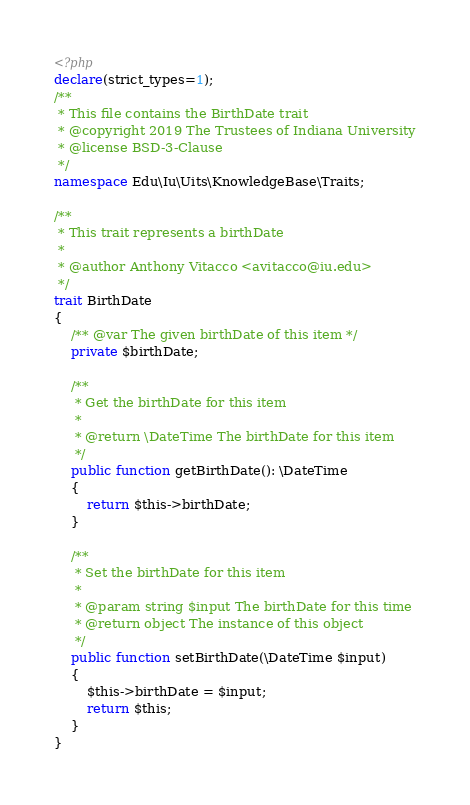Convert code to text. <code><loc_0><loc_0><loc_500><loc_500><_PHP_><?php
declare(strict_types=1);
/**
 * This file contains the BirthDate trait
 * @copyright 2019 The Trustees of Indiana University
 * @license BSD-3-Clause
 */
namespace Edu\Iu\Uits\KnowledgeBase\Traits;

/**
 * This trait represents a birthDate
 *
 * @author Anthony Vitacco <avitacco@iu.edu>
 */
trait BirthDate
{
    /** @var The given birthDate of this item */
    private $birthDate;
    
    /**
     * Get the birthDate for this item
     *
     * @return \DateTime The birthDate for this item
     */
    public function getBirthDate(): \DateTime
    {
        return $this->birthDate;
    }
    
    /**
     * Set the birthDate for this item
     *
     * @param string $input The birthDate for this time
     * @return object The instance of this object
     */
    public function setBirthDate(\DateTime $input)
    {
        $this->birthDate = $input;
        return $this;
    }
}
</code> 